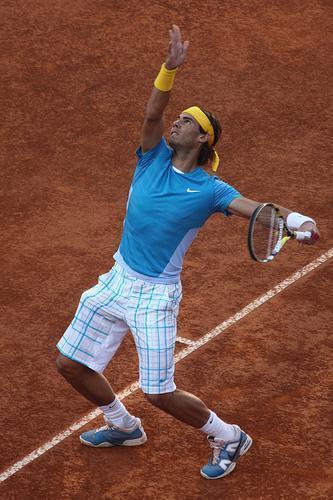How many men are there?
Give a very brief answer. 1. 